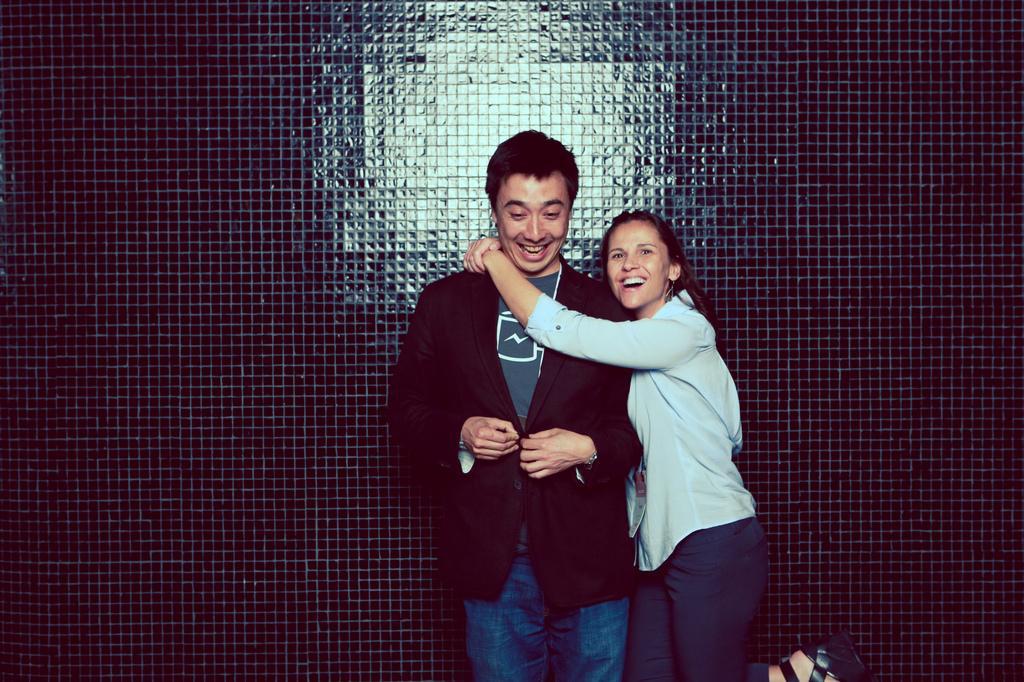Can you describe this image briefly? In this image we can see two persons smiling. Behind the persons we can see a wall. 